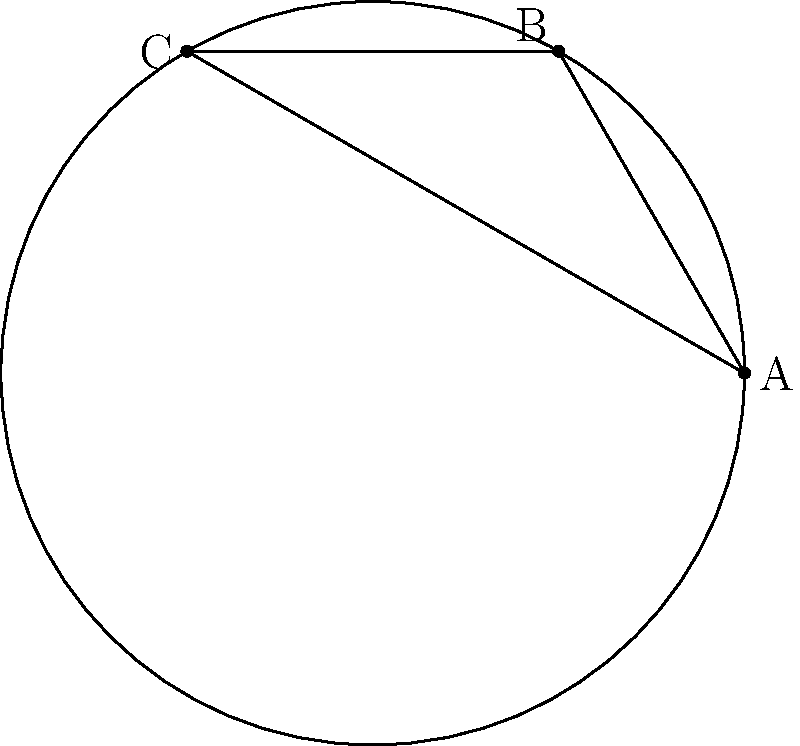In the context of elliptic geometry, as represented by the surface of a sphere, consider the image above showing a spherical triangle ABC. The blue dashed arcs represent great circles passing through each pair of points. How do these arcs relate to the concept of parallel lines in elliptic geometry, and what implications does this have for poverty alleviation strategies in developing regions with non-uniform resource distribution? To answer this question, let's break it down step-by-step:

1. In elliptic geometry, which is modeled on the surface of a sphere:
   - Straight lines are represented by great circles (the blue dashed arcs in the image).
   - Any two great circles always intersect at two antipodal points.

2. This means that in elliptic geometry:
   - There are no parallel lines, as all "straight lines" (great circles) eventually intersect.
   - The sum of the angles in a triangle is always greater than 180°.

3. Implications for poverty alleviation strategies:
   a) Non-linear approach: Just as there are no parallel lines in elliptic geometry, poverty alleviation strategies should not follow a "one-size-fits-all" linear approach.

   b) Interconnectedness: The intersecting nature of great circles suggests that different aspects of poverty are interconnected and should be addressed holistically.

   c) Resource distribution: In regions with non-uniform resource distribution (like the curved surface of a sphere), strategies need to adapt to local conditions rather than assuming uniform distribution.

   d) Multiple perspectives: The fact that any two points on a sphere can be connected by multiple great circles suggests that there may be multiple valid approaches to addressing poverty in a given situation.

   e) Curved thinking: Just as straight lines appear curved on a sphere, development practitioners should be prepared to "bend" traditional thinking to fit local contexts.

4. Practical application:
   - When designing poverty alleviation programs, consider the unique geographical, cultural, and economic "curvature" of each region.
   - Recognize that solutions that work in one area may not directly translate to another due to the "non-parallel" nature of development challenges.
   - Emphasize adaptive and flexible approaches that can adjust to the "spherical" nature of complex socio-economic systems.
Answer: In elliptic geometry, there are no parallel lines as all great circles intersect. This implies poverty alleviation strategies should be non-linear, interconnected, context-specific, and adaptable to local "curvatures" in resource distribution and socio-economic conditions. 